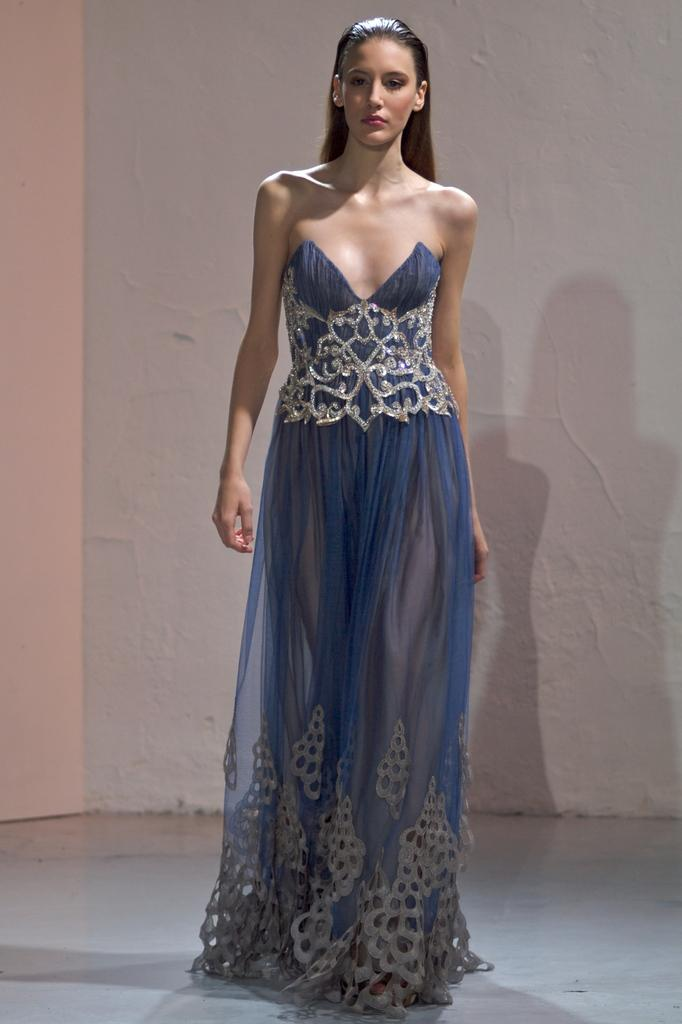What is the woman in the image doing? The woman is walking in the image. On what surface is the woman walking? The woman is walking on the floor. What can be seen in the background of the image? There is a white wall in the background of the image. What object is located on the left side of the image? There is an object that looks like a board on the left side of the image. What type of cushion is the woman using to balance herself while walking in the image? There is no cushion present in the image, and the woman is not shown using any object to balance herself while walking. 